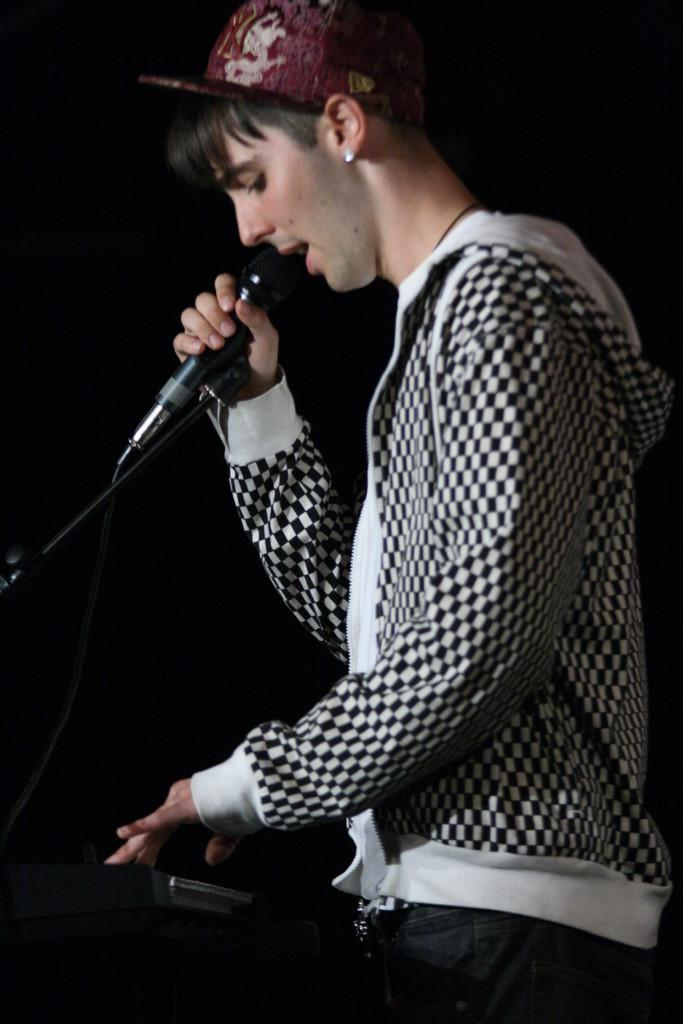What is the person in the image doing? The person is standing in the image and holding a microphone. What is the person wearing on their head? The person is wearing a cap. What type of clothing is the person wearing on their upper body? The person is wearing a checkered hoodie. What color is the background of the image? The background of the image is black. What type of interest does the person have in the picture? There is no information about the person's interests in the image. Can you see a fan in the image? There is no fan present in the image. 